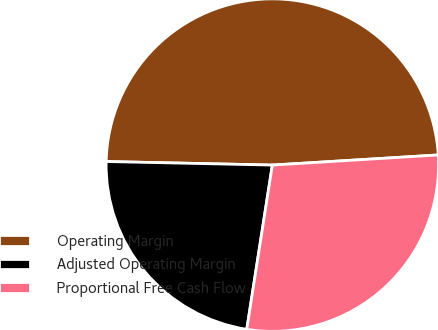Convert chart to OTSL. <chart><loc_0><loc_0><loc_500><loc_500><pie_chart><fcel>Operating Margin<fcel>Adjusted Operating Margin<fcel>Proportional Free Cash Flow<nl><fcel>48.69%<fcel>22.88%<fcel>28.43%<nl></chart> 